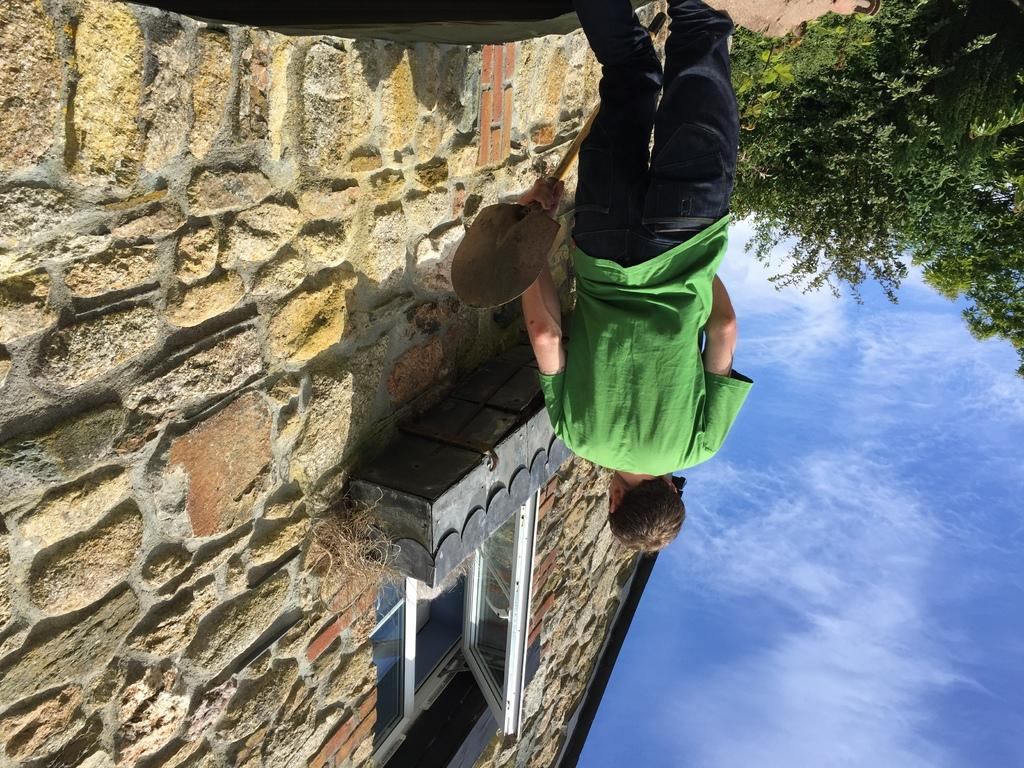What is the person in the image holding? The person is holding a paddle. What can be seen in the background of the image? There is a house in the background of the image. Can you describe the house in the image? The house has a wall and a glass window. What is present on the right side of the image? There are trees, plants, and the sky visible on the right side of the image. Can you see a giraffe swimming in the ocean in the image? No, there is no giraffe or ocean present in the image. 